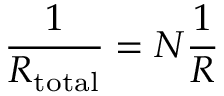Convert formula to latex. <formula><loc_0><loc_0><loc_500><loc_500>{ \frac { 1 } { R _ { t o t a l } } } = N { \frac { 1 } { R } }</formula> 